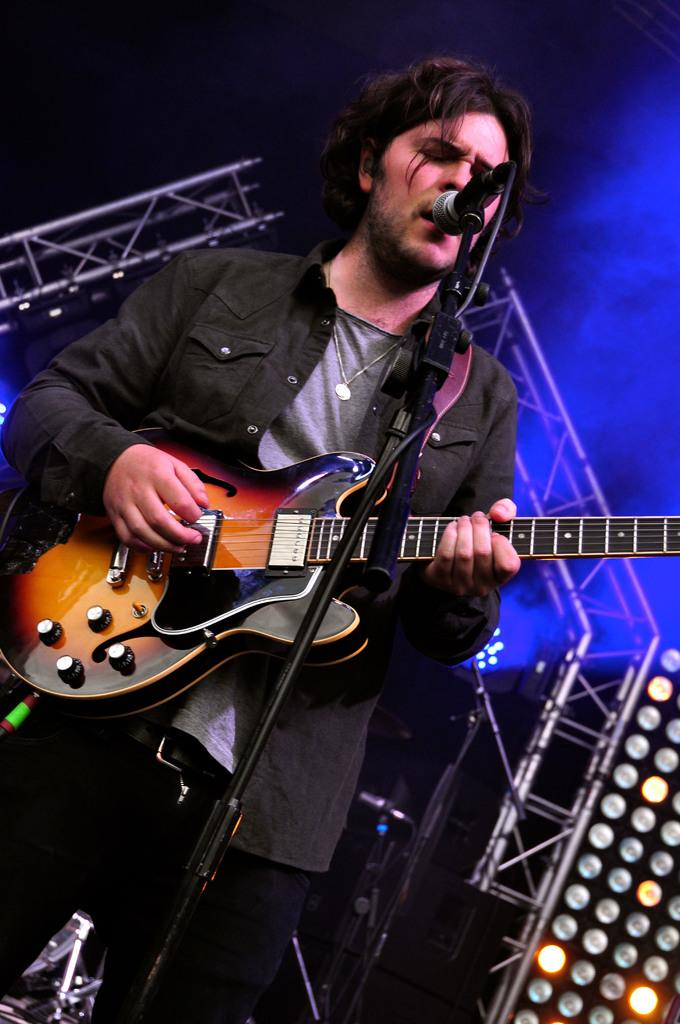Who is the main subject in the image? There is a man in the image. What is the man holding in the image? The man is holding a guitar. What is the man doing with the guitar? The man is playing the guitar. What device is in front of the man? There is a microphone in front of the man. What is the man doing with the microphone? The man is singing through the microphone. What can be seen in the background of the image? There is a set in the background of the image. How many houses are visible in the image? There are no houses visible in the image; it features a man playing a guitar and singing through a microphone. What type of mist can be seen surrounding the man in the image? There is no mist present in the image; it is a clear setting. 